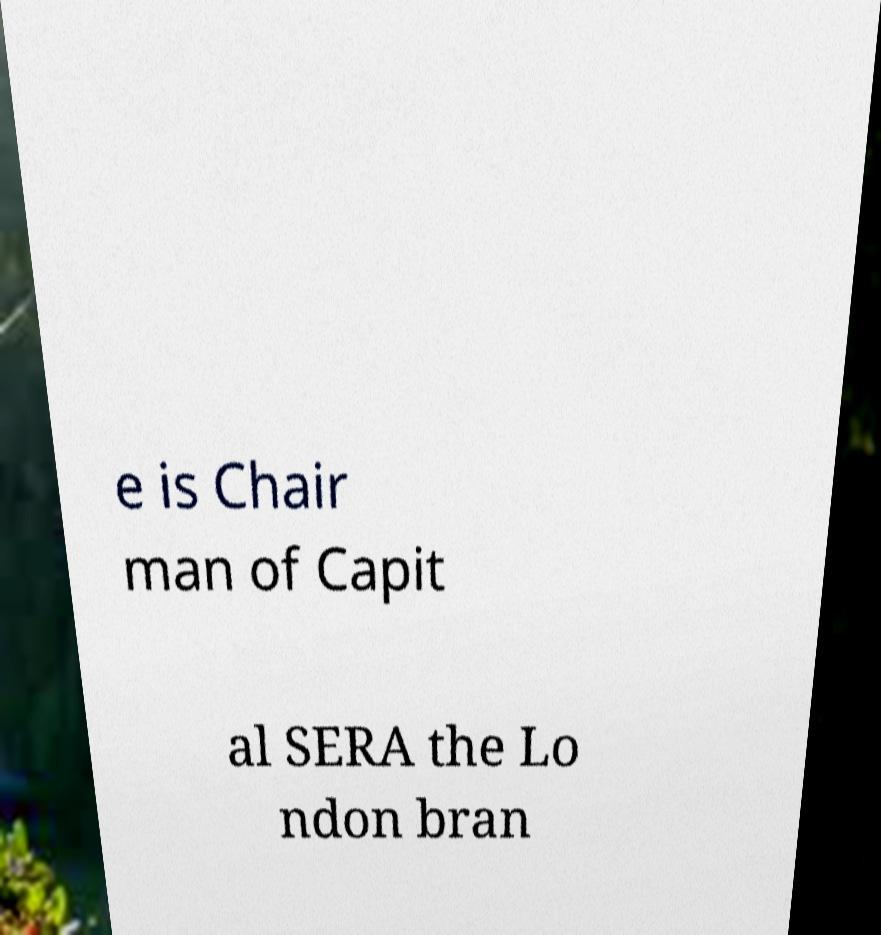What messages or text are displayed in this image? I need them in a readable, typed format. e is Chair man of Capit al SERA the Lo ndon bran 